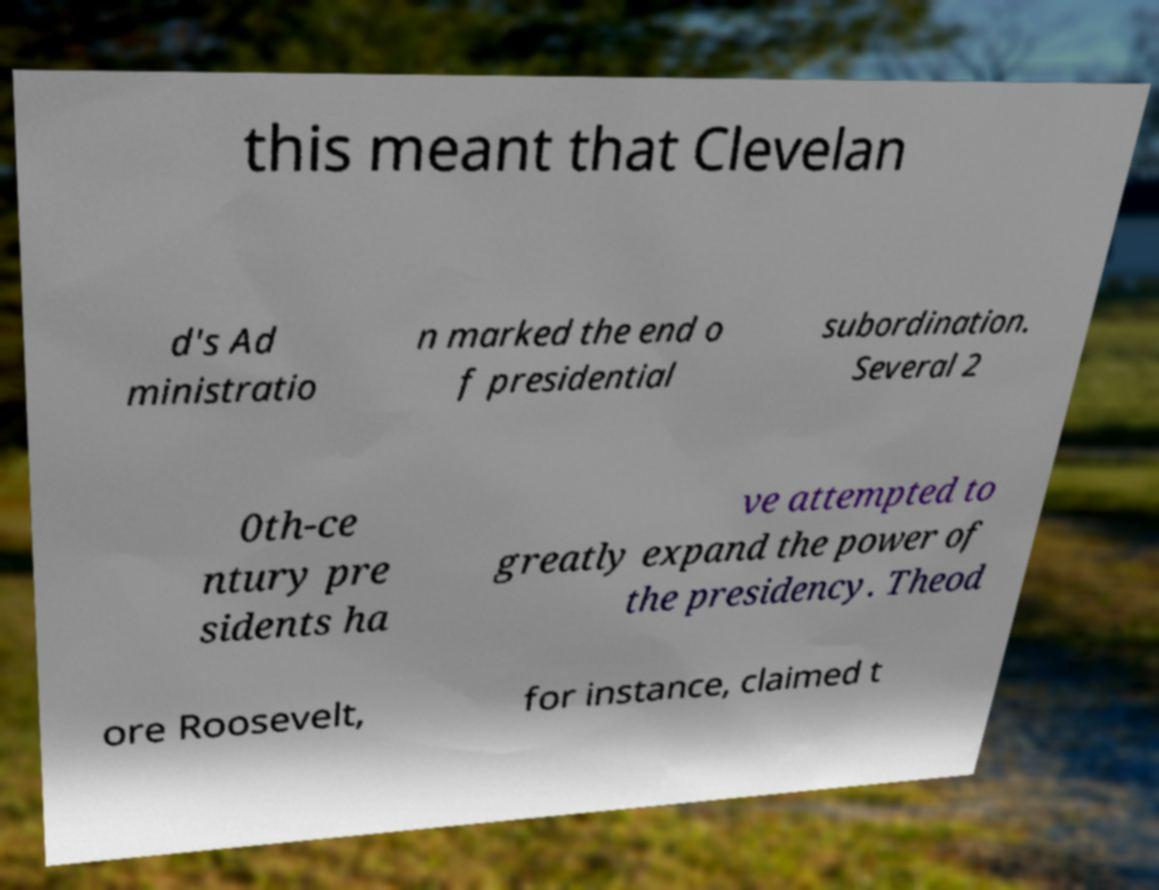Could you assist in decoding the text presented in this image and type it out clearly? this meant that Clevelan d's Ad ministratio n marked the end o f presidential subordination. Several 2 0th-ce ntury pre sidents ha ve attempted to greatly expand the power of the presidency. Theod ore Roosevelt, for instance, claimed t 